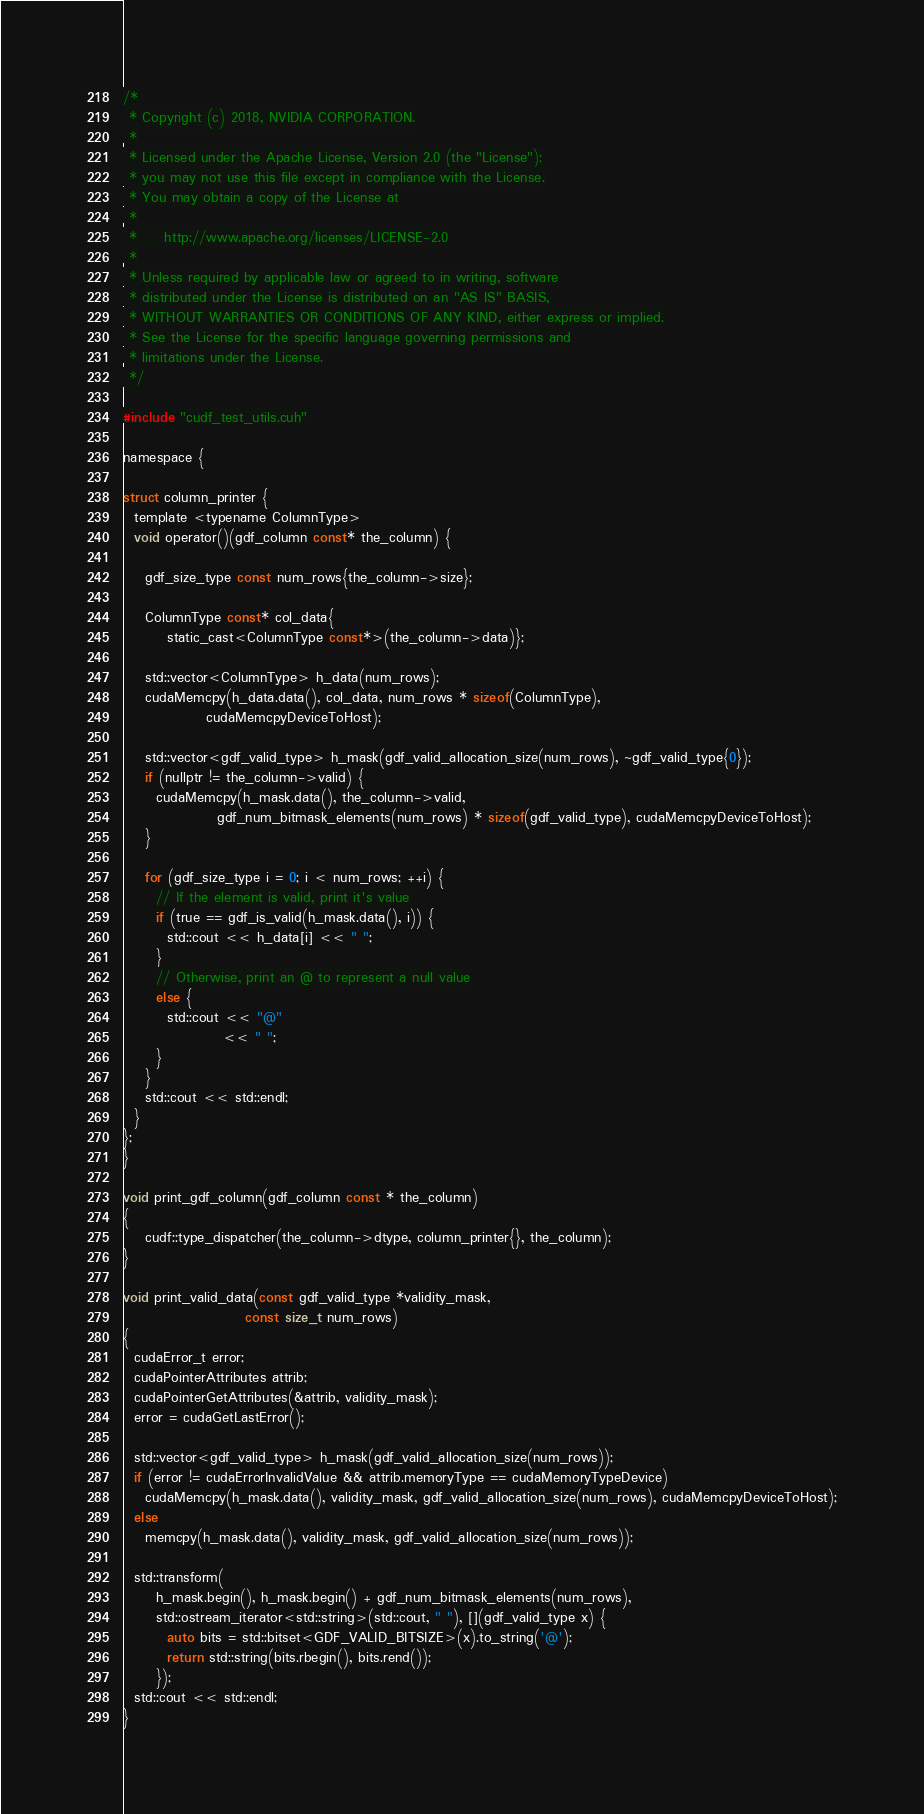Convert code to text. <code><loc_0><loc_0><loc_500><loc_500><_Cuda_>/*
 * Copyright (c) 2018, NVIDIA CORPORATION.
 *
 * Licensed under the Apache License, Version 2.0 (the "License");
 * you may not use this file except in compliance with the License.
 * You may obtain a copy of the License at
 *
 *     http://www.apache.org/licenses/LICENSE-2.0
 *
 * Unless required by applicable law or agreed to in writing, software
 * distributed under the License is distributed on an "AS IS" BASIS,
 * WITHOUT WARRANTIES OR CONDITIONS OF ANY KIND, either express or implied.
 * See the License for the specific language governing permissions and
 * limitations under the License.
 */

#include "cudf_test_utils.cuh"

namespace {

struct column_printer {
  template <typename ColumnType>
  void operator()(gdf_column const* the_column) {

    gdf_size_type const num_rows{the_column->size};

    ColumnType const* col_data{
        static_cast<ColumnType const*>(the_column->data)};

    std::vector<ColumnType> h_data(num_rows);
    cudaMemcpy(h_data.data(), col_data, num_rows * sizeof(ColumnType),
               cudaMemcpyDeviceToHost);

    std::vector<gdf_valid_type> h_mask(gdf_valid_allocation_size(num_rows), ~gdf_valid_type{0});
    if (nullptr != the_column->valid) {
      cudaMemcpy(h_mask.data(), the_column->valid,
                 gdf_num_bitmask_elements(num_rows) * sizeof(gdf_valid_type), cudaMemcpyDeviceToHost);
    }

    for (gdf_size_type i = 0; i < num_rows; ++i) {
      // If the element is valid, print it's value
      if (true == gdf_is_valid(h_mask.data(), i)) {
        std::cout << h_data[i] << " ";
      }
      // Otherwise, print an @ to represent a null value
      else {
        std::cout << "@"
                  << " ";
      }
    }
    std::cout << std::endl;
  }
};
}

void print_gdf_column(gdf_column const * the_column)
{
    cudf::type_dispatcher(the_column->dtype, column_printer{}, the_column);
}

void print_valid_data(const gdf_valid_type *validity_mask, 
                      const size_t num_rows)
{
  cudaError_t error;
  cudaPointerAttributes attrib;
  cudaPointerGetAttributes(&attrib, validity_mask);
  error = cudaGetLastError();

  std::vector<gdf_valid_type> h_mask(gdf_valid_allocation_size(num_rows));
  if (error != cudaErrorInvalidValue && attrib.memoryType == cudaMemoryTypeDevice)
    cudaMemcpy(h_mask.data(), validity_mask, gdf_valid_allocation_size(num_rows), cudaMemcpyDeviceToHost);
  else
    memcpy(h_mask.data(), validity_mask, gdf_valid_allocation_size(num_rows));

  std::transform(
      h_mask.begin(), h_mask.begin() + gdf_num_bitmask_elements(num_rows),
      std::ostream_iterator<std::string>(std::cout, " "), [](gdf_valid_type x) {
        auto bits = std::bitset<GDF_VALID_BITSIZE>(x).to_string('@');
        return std::string(bits.rbegin(), bits.rend());
      });
  std::cout << std::endl;
}

</code> 